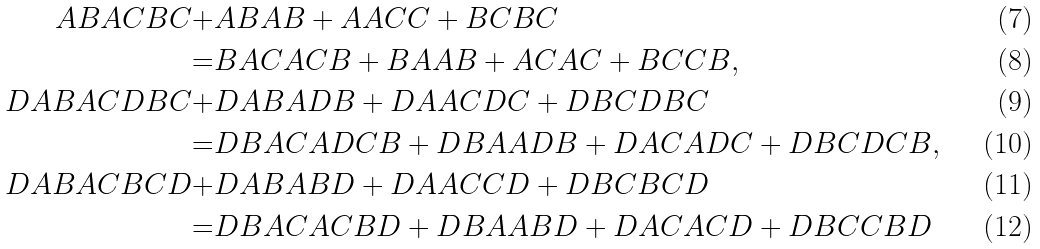<formula> <loc_0><loc_0><loc_500><loc_500>A B A C B C + & A B A B + A A C C + B C B C \\ = & B A C A C B + B A A B + A C A C + B C C B , \\ D A B A C D B C + & D A B A D B + D A A C D C + D B C D B C \\ = & D B A C A D C B + D B A A D B + D A C A D C + D B C D C B , \\ D A B A C B C D + & D A B A B D + D A A C C D + D B C B C D \\ = & D B A C A C B D + D B A A B D + D A C A C D + D B C C B D</formula> 